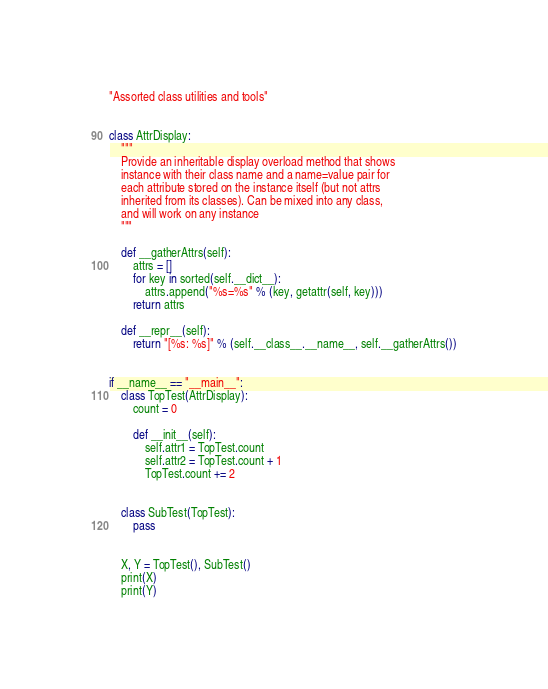Convert code to text. <code><loc_0><loc_0><loc_500><loc_500><_Python_>"Assorted class utilities and tools"


class AttrDisplay:
    """
    Provide an inheritable display overload method that shows
    instance with their class name and a name=value pair for
    each attribute stored on the instance itself (but not attrs
    inherited from its classes). Can be mixed into any class,
    and will work on any instance
    """

    def __gatherAttrs(self):
        attrs = []
        for key in sorted(self.__dict__):
            attrs.append("%s=%s" % (key, getattr(self, key)))
        return attrs

    def __repr__(self):
        return "[%s: %s]" % (self.__class__.__name__, self.__gatherAttrs())


if __name__ == "__main__":
    class TopTest(AttrDisplay):
        count = 0

        def __init__(self):
            self.attr1 = TopTest.count
            self.attr2 = TopTest.count + 1
            TopTest.count += 2


    class SubTest(TopTest):
        pass


    X, Y = TopTest(), SubTest()
    print(X)
    print(Y)
</code> 